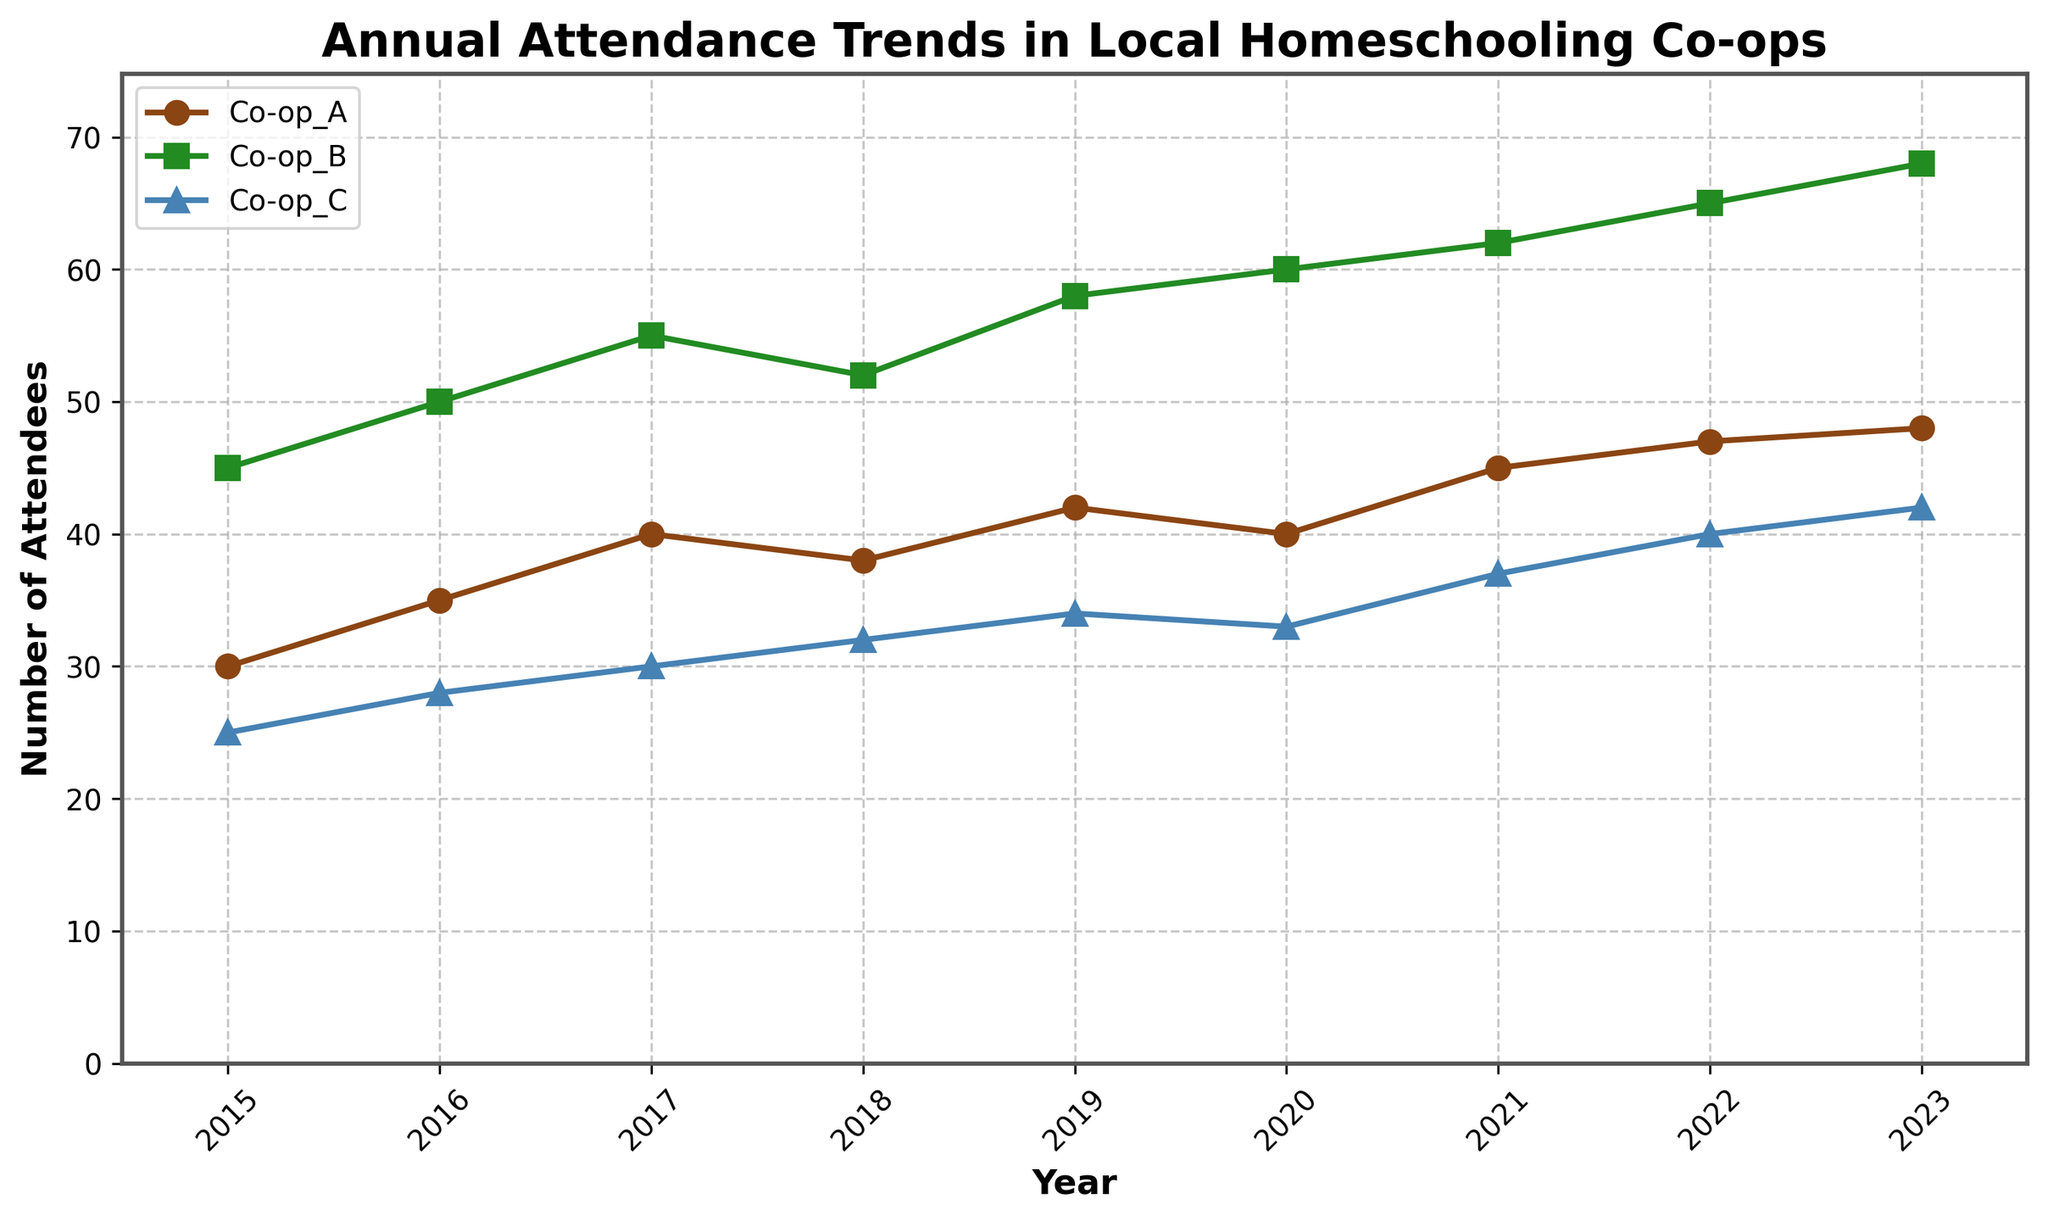What's the title of the plot? The title is written at the top of the plot, and it describes the overall content.
Answer: Annual Attendance Trends in Local Homeschooling Co-ops What is the y-axis label? The y-axis label, usually located on the left side of the plot, identifies what is being measured on that axis.
Answer: Number of Attendees Which Co-op had the highest number of attendees in 2023? Observing the plot, the line representing Co-op B is the highest in 2023.
Answer: Co-op B How many years are covered in the plot? Counting the number of ticks on the x-axis reveals the range of years included.
Answer: 9 years What is the trend for Co-op A from 2015 to 2023? Following the line representing Co-op A from left to right, we observe it generally increases.
Answer: Increasing What is the difference in the number of attendees between Co-op A and Co-op B in 2023? Co-op A had 48 attendees and Co-op B had 68 attendees in 2023. Subtracting these gives the difference.
Answer: 20 attendees How did the number of attendees for Co-op C change from 2019 to 2020? Co-op C had 34 attendees in 2019 and 33 in 2020, showing a slight decrease.
Answer: Decreased by 1 Which Co-op showed the most consistent growth over the years? Co-op B consistently increases every year without any declines.
Answer: Co-op B Which year did Co-op B surpass Co-op A in the number of attendees? Tracing the lines of Co-op A and Co-op B, Co-op B surpasses Co-op A in 2016.
Answer: 2016 In which year did Co-op C have the minimum number of attendees? The lowest point on Co-op C's line is at the very beginning in 2015.
Answer: 2015 